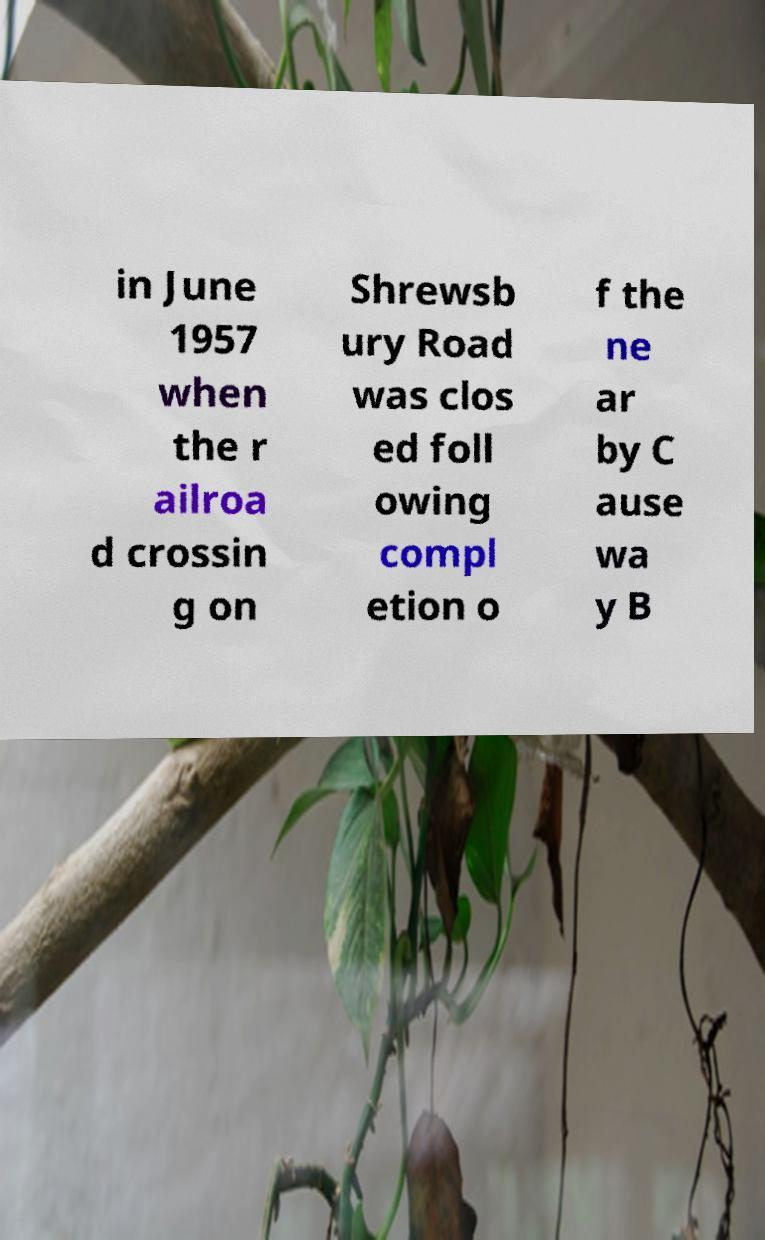Please read and relay the text visible in this image. What does it say? in June 1957 when the r ailroa d crossin g on Shrewsb ury Road was clos ed foll owing compl etion o f the ne ar by C ause wa y B 